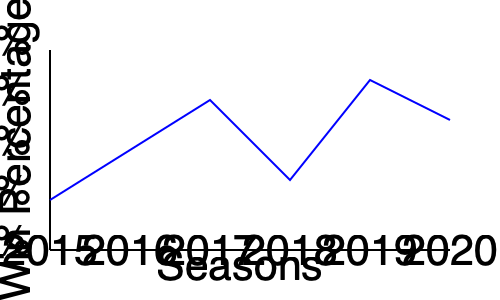Based on the line graph showing the Patriots' win percentage over six seasons, calculate the average win percentage for the 2015-2017 period and compare it to the average win percentage for the 2018-2020 period. Which period had a higher average win percentage, and by how much? To solve this problem, we'll follow these steps:

1. Estimate the win percentages for each season from the graph:
   2015: ~62.5%
   2016: ~75%
   2017: ~87.5%
   2018: ~56.25%
   2019: ~93.75%
   2020: ~81.25%

2. Calculate the average win percentage for 2015-2017:
   $\frac{62.5\% + 75\% + 87.5\%}{3} = \frac{225\%}{3} = 75\%$

3. Calculate the average win percentage for 2018-2020:
   $\frac{56.25\% + 93.75\% + 81.25\%}{3} = \frac{231.25\%}{3} = 77.08\%$

4. Compare the two averages:
   $77.08\% - 75\% = 2.08\%$

The 2018-2020 period had a higher average win percentage by 2.08%.
Answer: 2018-2020 period; 2.08% higher 